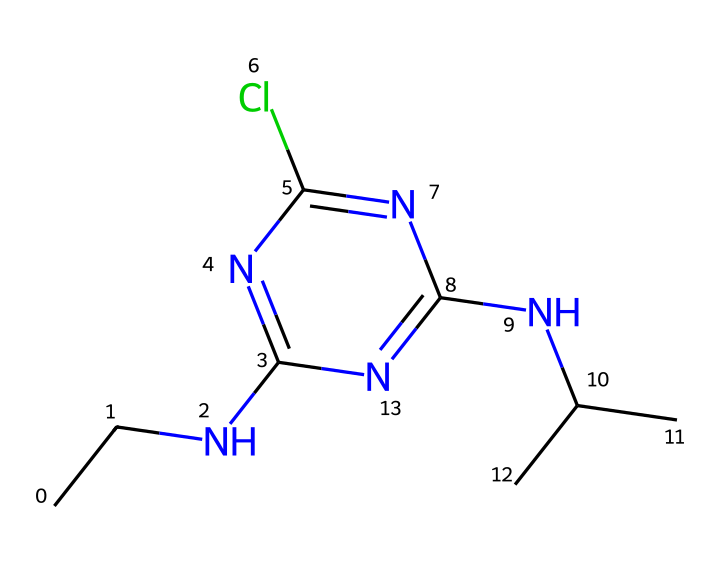What is the chemical name of the substance represented by the SMILES? The SMILES representation indicates the presence of various elements and their arrangement, which corresponds to atrazine, a well-known herbicide.
Answer: atrazine How many nitrogen atoms are present in the chemical structure? By examining the SMILES, we find three nitrogen atoms (N) indicated in the structure itself.
Answer: three What is the total number of chlorine atoms in this chemical? The SMILES contains one 'Cl', indicating that there is only one chlorine atom in the chemical structure.
Answer: one Is the chemical structure primarily composed of carbon or nitrogen? By counting the carbon (C) and nitrogen (N) atoms in the SMILES, there are more carbon atoms (eight) than nitrogen atoms (three), indicating it is primarily carbon.
Answer: carbon Which functional group does atrazine belong to based on its structure? The presence of nitrogen atoms and the specific arrangement in the structure suggests that atrazine belongs to the group of organic amines, due to its amine functional group.
Answer: amine Does this herbicide have any branches in its carbon structure? Analyzing the SMILES, we see branches indicated by 'C(C)', showing that there are branched connections in the carbon skeleton.
Answer: yes How many total bonds are formed in the atrazine structure? By visualizing the connections in the SMILES, we can count the total number of bonds formed, which come primarily from carbon-to-carbon and carbon-to-nitrogen connections; there are multiple single bonds and possibly a double bond. The precise count leads to a total of 10 bonds.
Answer: ten 